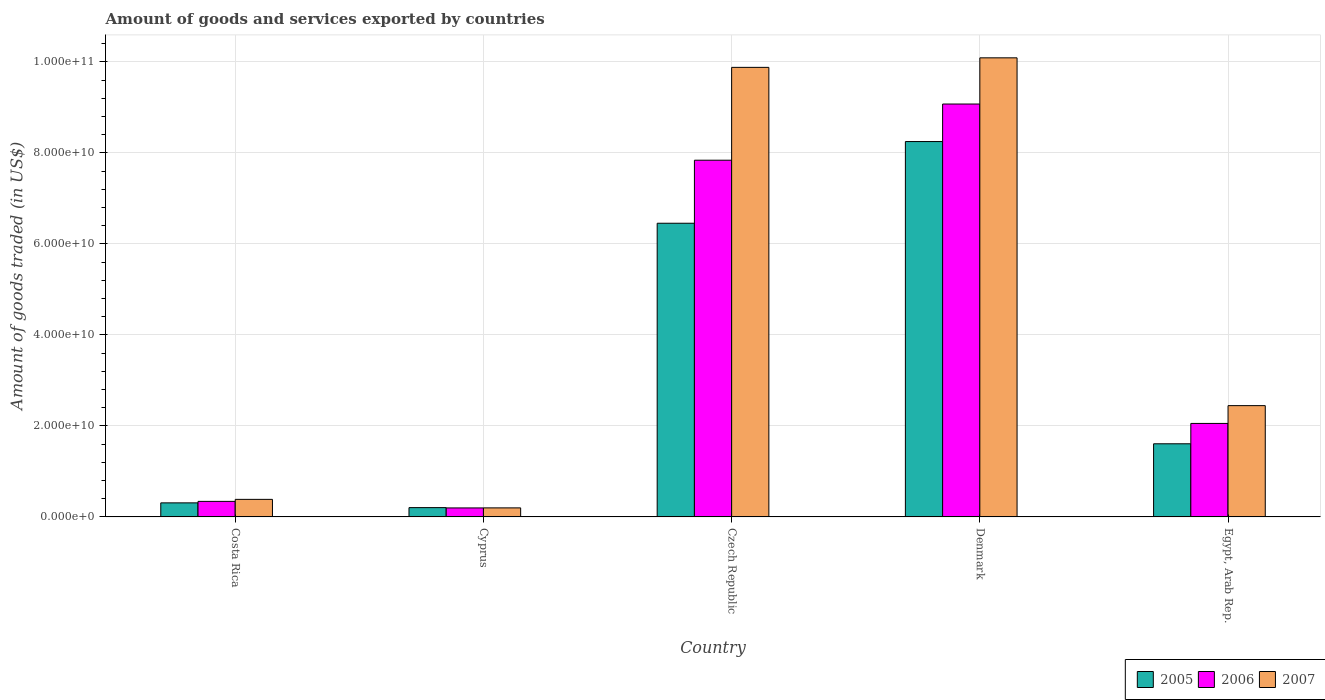How many groups of bars are there?
Give a very brief answer. 5. Are the number of bars per tick equal to the number of legend labels?
Provide a succinct answer. Yes. How many bars are there on the 4th tick from the left?
Give a very brief answer. 3. How many bars are there on the 4th tick from the right?
Keep it short and to the point. 3. What is the label of the 5th group of bars from the left?
Provide a succinct answer. Egypt, Arab Rep. What is the total amount of goods and services exported in 2006 in Denmark?
Keep it short and to the point. 9.07e+1. Across all countries, what is the maximum total amount of goods and services exported in 2007?
Keep it short and to the point. 1.01e+11. Across all countries, what is the minimum total amount of goods and services exported in 2006?
Give a very brief answer. 1.98e+09. In which country was the total amount of goods and services exported in 2005 minimum?
Your response must be concise. Cyprus. What is the total total amount of goods and services exported in 2005 in the graph?
Give a very brief answer. 1.68e+11. What is the difference between the total amount of goods and services exported in 2006 in Cyprus and that in Czech Republic?
Ensure brevity in your answer.  -7.64e+1. What is the difference between the total amount of goods and services exported in 2006 in Cyprus and the total amount of goods and services exported in 2007 in Czech Republic?
Make the answer very short. -9.68e+1. What is the average total amount of goods and services exported in 2007 per country?
Your answer should be very brief. 4.60e+1. What is the difference between the total amount of goods and services exported of/in 2006 and total amount of goods and services exported of/in 2007 in Egypt, Arab Rep.?
Give a very brief answer. -3.91e+09. In how many countries, is the total amount of goods and services exported in 2007 greater than 24000000000 US$?
Your answer should be very brief. 3. What is the ratio of the total amount of goods and services exported in 2005 in Costa Rica to that in Czech Republic?
Keep it short and to the point. 0.05. Is the total amount of goods and services exported in 2006 in Costa Rica less than that in Denmark?
Offer a terse response. Yes. Is the difference between the total amount of goods and services exported in 2006 in Costa Rica and Egypt, Arab Rep. greater than the difference between the total amount of goods and services exported in 2007 in Costa Rica and Egypt, Arab Rep.?
Your answer should be compact. Yes. What is the difference between the highest and the second highest total amount of goods and services exported in 2005?
Your answer should be compact. -4.85e+1. What is the difference between the highest and the lowest total amount of goods and services exported in 2005?
Your answer should be compact. 8.04e+1. In how many countries, is the total amount of goods and services exported in 2005 greater than the average total amount of goods and services exported in 2005 taken over all countries?
Offer a very short reply. 2. Is the sum of the total amount of goods and services exported in 2005 in Czech Republic and Egypt, Arab Rep. greater than the maximum total amount of goods and services exported in 2007 across all countries?
Give a very brief answer. No. Are all the bars in the graph horizontal?
Offer a very short reply. No. How many countries are there in the graph?
Your response must be concise. 5. What is the difference between two consecutive major ticks on the Y-axis?
Your response must be concise. 2.00e+1. Are the values on the major ticks of Y-axis written in scientific E-notation?
Offer a very short reply. Yes. How many legend labels are there?
Your answer should be very brief. 3. How are the legend labels stacked?
Keep it short and to the point. Horizontal. What is the title of the graph?
Provide a succinct answer. Amount of goods and services exported by countries. Does "1966" appear as one of the legend labels in the graph?
Give a very brief answer. No. What is the label or title of the Y-axis?
Your answer should be compact. Amount of goods traded (in US$). What is the Amount of goods traded (in US$) of 2005 in Costa Rica?
Your answer should be very brief. 3.09e+09. What is the Amount of goods traded (in US$) in 2006 in Costa Rica?
Your answer should be compact. 3.42e+09. What is the Amount of goods traded (in US$) in 2007 in Costa Rica?
Provide a short and direct response. 3.86e+09. What is the Amount of goods traded (in US$) in 2005 in Cyprus?
Your answer should be compact. 2.05e+09. What is the Amount of goods traded (in US$) in 2006 in Cyprus?
Your response must be concise. 1.98e+09. What is the Amount of goods traded (in US$) of 2007 in Cyprus?
Ensure brevity in your answer.  1.99e+09. What is the Amount of goods traded (in US$) of 2005 in Czech Republic?
Offer a terse response. 6.45e+1. What is the Amount of goods traded (in US$) in 2006 in Czech Republic?
Your answer should be compact. 7.84e+1. What is the Amount of goods traded (in US$) of 2007 in Czech Republic?
Provide a succinct answer. 9.88e+1. What is the Amount of goods traded (in US$) of 2005 in Denmark?
Give a very brief answer. 8.25e+1. What is the Amount of goods traded (in US$) of 2006 in Denmark?
Your answer should be very brief. 9.07e+1. What is the Amount of goods traded (in US$) of 2007 in Denmark?
Keep it short and to the point. 1.01e+11. What is the Amount of goods traded (in US$) of 2005 in Egypt, Arab Rep.?
Your response must be concise. 1.61e+1. What is the Amount of goods traded (in US$) in 2006 in Egypt, Arab Rep.?
Ensure brevity in your answer.  2.05e+1. What is the Amount of goods traded (in US$) in 2007 in Egypt, Arab Rep.?
Your answer should be compact. 2.45e+1. Across all countries, what is the maximum Amount of goods traded (in US$) of 2005?
Your response must be concise. 8.25e+1. Across all countries, what is the maximum Amount of goods traded (in US$) in 2006?
Your response must be concise. 9.07e+1. Across all countries, what is the maximum Amount of goods traded (in US$) of 2007?
Provide a succinct answer. 1.01e+11. Across all countries, what is the minimum Amount of goods traded (in US$) of 2005?
Ensure brevity in your answer.  2.05e+09. Across all countries, what is the minimum Amount of goods traded (in US$) in 2006?
Offer a terse response. 1.98e+09. Across all countries, what is the minimum Amount of goods traded (in US$) in 2007?
Provide a short and direct response. 1.99e+09. What is the total Amount of goods traded (in US$) of 2005 in the graph?
Provide a succinct answer. 1.68e+11. What is the total Amount of goods traded (in US$) in 2006 in the graph?
Provide a short and direct response. 1.95e+11. What is the total Amount of goods traded (in US$) of 2007 in the graph?
Give a very brief answer. 2.30e+11. What is the difference between the Amount of goods traded (in US$) of 2005 in Costa Rica and that in Cyprus?
Your answer should be very brief. 1.04e+09. What is the difference between the Amount of goods traded (in US$) in 2006 in Costa Rica and that in Cyprus?
Give a very brief answer. 1.44e+09. What is the difference between the Amount of goods traded (in US$) of 2007 in Costa Rica and that in Cyprus?
Keep it short and to the point. 1.87e+09. What is the difference between the Amount of goods traded (in US$) of 2005 in Costa Rica and that in Czech Republic?
Give a very brief answer. -6.14e+1. What is the difference between the Amount of goods traded (in US$) in 2006 in Costa Rica and that in Czech Republic?
Provide a succinct answer. -7.50e+1. What is the difference between the Amount of goods traded (in US$) of 2007 in Costa Rica and that in Czech Republic?
Offer a terse response. -9.49e+1. What is the difference between the Amount of goods traded (in US$) of 2005 in Costa Rica and that in Denmark?
Provide a succinct answer. -7.94e+1. What is the difference between the Amount of goods traded (in US$) in 2006 in Costa Rica and that in Denmark?
Offer a terse response. -8.73e+1. What is the difference between the Amount of goods traded (in US$) in 2007 in Costa Rica and that in Denmark?
Your answer should be very brief. -9.70e+1. What is the difference between the Amount of goods traded (in US$) of 2005 in Costa Rica and that in Egypt, Arab Rep.?
Your response must be concise. -1.30e+1. What is the difference between the Amount of goods traded (in US$) in 2006 in Costa Rica and that in Egypt, Arab Rep.?
Offer a terse response. -1.71e+1. What is the difference between the Amount of goods traded (in US$) of 2007 in Costa Rica and that in Egypt, Arab Rep.?
Offer a terse response. -2.06e+1. What is the difference between the Amount of goods traded (in US$) in 2005 in Cyprus and that in Czech Republic?
Offer a terse response. -6.25e+1. What is the difference between the Amount of goods traded (in US$) of 2006 in Cyprus and that in Czech Republic?
Ensure brevity in your answer.  -7.64e+1. What is the difference between the Amount of goods traded (in US$) in 2007 in Cyprus and that in Czech Republic?
Provide a succinct answer. -9.68e+1. What is the difference between the Amount of goods traded (in US$) in 2005 in Cyprus and that in Denmark?
Keep it short and to the point. -8.04e+1. What is the difference between the Amount of goods traded (in US$) in 2006 in Cyprus and that in Denmark?
Keep it short and to the point. -8.88e+1. What is the difference between the Amount of goods traded (in US$) of 2007 in Cyprus and that in Denmark?
Offer a terse response. -9.89e+1. What is the difference between the Amount of goods traded (in US$) of 2005 in Cyprus and that in Egypt, Arab Rep.?
Offer a very short reply. -1.40e+1. What is the difference between the Amount of goods traded (in US$) in 2006 in Cyprus and that in Egypt, Arab Rep.?
Make the answer very short. -1.86e+1. What is the difference between the Amount of goods traded (in US$) of 2007 in Cyprus and that in Egypt, Arab Rep.?
Make the answer very short. -2.25e+1. What is the difference between the Amount of goods traded (in US$) in 2005 in Czech Republic and that in Denmark?
Give a very brief answer. -1.80e+1. What is the difference between the Amount of goods traded (in US$) of 2006 in Czech Republic and that in Denmark?
Your response must be concise. -1.23e+1. What is the difference between the Amount of goods traded (in US$) in 2007 in Czech Republic and that in Denmark?
Your response must be concise. -2.09e+09. What is the difference between the Amount of goods traded (in US$) in 2005 in Czech Republic and that in Egypt, Arab Rep.?
Give a very brief answer. 4.85e+1. What is the difference between the Amount of goods traded (in US$) in 2006 in Czech Republic and that in Egypt, Arab Rep.?
Provide a short and direct response. 5.78e+1. What is the difference between the Amount of goods traded (in US$) in 2007 in Czech Republic and that in Egypt, Arab Rep.?
Give a very brief answer. 7.43e+1. What is the difference between the Amount of goods traded (in US$) of 2005 in Denmark and that in Egypt, Arab Rep.?
Provide a short and direct response. 6.64e+1. What is the difference between the Amount of goods traded (in US$) in 2006 in Denmark and that in Egypt, Arab Rep.?
Offer a very short reply. 7.02e+1. What is the difference between the Amount of goods traded (in US$) of 2007 in Denmark and that in Egypt, Arab Rep.?
Your response must be concise. 7.64e+1. What is the difference between the Amount of goods traded (in US$) of 2005 in Costa Rica and the Amount of goods traded (in US$) of 2006 in Cyprus?
Provide a succinct answer. 1.11e+09. What is the difference between the Amount of goods traded (in US$) in 2005 in Costa Rica and the Amount of goods traded (in US$) in 2007 in Cyprus?
Provide a short and direct response. 1.10e+09. What is the difference between the Amount of goods traded (in US$) of 2006 in Costa Rica and the Amount of goods traded (in US$) of 2007 in Cyprus?
Keep it short and to the point. 1.43e+09. What is the difference between the Amount of goods traded (in US$) of 2005 in Costa Rica and the Amount of goods traded (in US$) of 2006 in Czech Republic?
Give a very brief answer. -7.53e+1. What is the difference between the Amount of goods traded (in US$) in 2005 in Costa Rica and the Amount of goods traded (in US$) in 2007 in Czech Republic?
Offer a very short reply. -9.57e+1. What is the difference between the Amount of goods traded (in US$) in 2006 in Costa Rica and the Amount of goods traded (in US$) in 2007 in Czech Republic?
Provide a short and direct response. -9.54e+1. What is the difference between the Amount of goods traded (in US$) in 2005 in Costa Rica and the Amount of goods traded (in US$) in 2006 in Denmark?
Ensure brevity in your answer.  -8.76e+1. What is the difference between the Amount of goods traded (in US$) in 2005 in Costa Rica and the Amount of goods traded (in US$) in 2007 in Denmark?
Keep it short and to the point. -9.78e+1. What is the difference between the Amount of goods traded (in US$) in 2006 in Costa Rica and the Amount of goods traded (in US$) in 2007 in Denmark?
Offer a very short reply. -9.75e+1. What is the difference between the Amount of goods traded (in US$) in 2005 in Costa Rica and the Amount of goods traded (in US$) in 2006 in Egypt, Arab Rep.?
Give a very brief answer. -1.75e+1. What is the difference between the Amount of goods traded (in US$) of 2005 in Costa Rica and the Amount of goods traded (in US$) of 2007 in Egypt, Arab Rep.?
Offer a very short reply. -2.14e+1. What is the difference between the Amount of goods traded (in US$) in 2006 in Costa Rica and the Amount of goods traded (in US$) in 2007 in Egypt, Arab Rep.?
Your answer should be compact. -2.10e+1. What is the difference between the Amount of goods traded (in US$) in 2005 in Cyprus and the Amount of goods traded (in US$) in 2006 in Czech Republic?
Keep it short and to the point. -7.63e+1. What is the difference between the Amount of goods traded (in US$) in 2005 in Cyprus and the Amount of goods traded (in US$) in 2007 in Czech Republic?
Ensure brevity in your answer.  -9.67e+1. What is the difference between the Amount of goods traded (in US$) of 2006 in Cyprus and the Amount of goods traded (in US$) of 2007 in Czech Republic?
Ensure brevity in your answer.  -9.68e+1. What is the difference between the Amount of goods traded (in US$) of 2005 in Cyprus and the Amount of goods traded (in US$) of 2006 in Denmark?
Your answer should be compact. -8.87e+1. What is the difference between the Amount of goods traded (in US$) in 2005 in Cyprus and the Amount of goods traded (in US$) in 2007 in Denmark?
Make the answer very short. -9.88e+1. What is the difference between the Amount of goods traded (in US$) of 2006 in Cyprus and the Amount of goods traded (in US$) of 2007 in Denmark?
Give a very brief answer. -9.89e+1. What is the difference between the Amount of goods traded (in US$) of 2005 in Cyprus and the Amount of goods traded (in US$) of 2006 in Egypt, Arab Rep.?
Ensure brevity in your answer.  -1.85e+1. What is the difference between the Amount of goods traded (in US$) in 2005 in Cyprus and the Amount of goods traded (in US$) in 2007 in Egypt, Arab Rep.?
Make the answer very short. -2.24e+1. What is the difference between the Amount of goods traded (in US$) in 2006 in Cyprus and the Amount of goods traded (in US$) in 2007 in Egypt, Arab Rep.?
Keep it short and to the point. -2.25e+1. What is the difference between the Amount of goods traded (in US$) in 2005 in Czech Republic and the Amount of goods traded (in US$) in 2006 in Denmark?
Ensure brevity in your answer.  -2.62e+1. What is the difference between the Amount of goods traded (in US$) in 2005 in Czech Republic and the Amount of goods traded (in US$) in 2007 in Denmark?
Your response must be concise. -3.63e+1. What is the difference between the Amount of goods traded (in US$) of 2006 in Czech Republic and the Amount of goods traded (in US$) of 2007 in Denmark?
Offer a terse response. -2.25e+1. What is the difference between the Amount of goods traded (in US$) of 2005 in Czech Republic and the Amount of goods traded (in US$) of 2006 in Egypt, Arab Rep.?
Provide a short and direct response. 4.40e+1. What is the difference between the Amount of goods traded (in US$) in 2005 in Czech Republic and the Amount of goods traded (in US$) in 2007 in Egypt, Arab Rep.?
Your answer should be very brief. 4.01e+1. What is the difference between the Amount of goods traded (in US$) in 2006 in Czech Republic and the Amount of goods traded (in US$) in 2007 in Egypt, Arab Rep.?
Your response must be concise. 5.39e+1. What is the difference between the Amount of goods traded (in US$) of 2005 in Denmark and the Amount of goods traded (in US$) of 2006 in Egypt, Arab Rep.?
Ensure brevity in your answer.  6.19e+1. What is the difference between the Amount of goods traded (in US$) of 2005 in Denmark and the Amount of goods traded (in US$) of 2007 in Egypt, Arab Rep.?
Your answer should be very brief. 5.80e+1. What is the difference between the Amount of goods traded (in US$) of 2006 in Denmark and the Amount of goods traded (in US$) of 2007 in Egypt, Arab Rep.?
Provide a short and direct response. 6.63e+1. What is the average Amount of goods traded (in US$) of 2005 per country?
Provide a succinct answer. 3.36e+1. What is the average Amount of goods traded (in US$) of 2006 per country?
Provide a short and direct response. 3.90e+1. What is the average Amount of goods traded (in US$) in 2007 per country?
Make the answer very short. 4.60e+1. What is the difference between the Amount of goods traded (in US$) of 2005 and Amount of goods traded (in US$) of 2006 in Costa Rica?
Your response must be concise. -3.27e+08. What is the difference between the Amount of goods traded (in US$) in 2005 and Amount of goods traded (in US$) in 2007 in Costa Rica?
Ensure brevity in your answer.  -7.72e+08. What is the difference between the Amount of goods traded (in US$) of 2006 and Amount of goods traded (in US$) of 2007 in Costa Rica?
Make the answer very short. -4.45e+08. What is the difference between the Amount of goods traded (in US$) in 2005 and Amount of goods traded (in US$) in 2006 in Cyprus?
Provide a succinct answer. 6.64e+07. What is the difference between the Amount of goods traded (in US$) of 2005 and Amount of goods traded (in US$) of 2007 in Cyprus?
Your answer should be compact. 5.92e+07. What is the difference between the Amount of goods traded (in US$) of 2006 and Amount of goods traded (in US$) of 2007 in Cyprus?
Make the answer very short. -7.27e+06. What is the difference between the Amount of goods traded (in US$) in 2005 and Amount of goods traded (in US$) in 2006 in Czech Republic?
Ensure brevity in your answer.  -1.38e+1. What is the difference between the Amount of goods traded (in US$) of 2005 and Amount of goods traded (in US$) of 2007 in Czech Republic?
Your answer should be very brief. -3.43e+1. What is the difference between the Amount of goods traded (in US$) in 2006 and Amount of goods traded (in US$) in 2007 in Czech Republic?
Provide a succinct answer. -2.04e+1. What is the difference between the Amount of goods traded (in US$) of 2005 and Amount of goods traded (in US$) of 2006 in Denmark?
Ensure brevity in your answer.  -8.25e+09. What is the difference between the Amount of goods traded (in US$) of 2005 and Amount of goods traded (in US$) of 2007 in Denmark?
Give a very brief answer. -1.84e+1. What is the difference between the Amount of goods traded (in US$) in 2006 and Amount of goods traded (in US$) in 2007 in Denmark?
Give a very brief answer. -1.01e+1. What is the difference between the Amount of goods traded (in US$) in 2005 and Amount of goods traded (in US$) in 2006 in Egypt, Arab Rep.?
Offer a terse response. -4.47e+09. What is the difference between the Amount of goods traded (in US$) of 2005 and Amount of goods traded (in US$) of 2007 in Egypt, Arab Rep.?
Provide a short and direct response. -8.38e+09. What is the difference between the Amount of goods traded (in US$) in 2006 and Amount of goods traded (in US$) in 2007 in Egypt, Arab Rep.?
Keep it short and to the point. -3.91e+09. What is the ratio of the Amount of goods traded (in US$) in 2005 in Costa Rica to that in Cyprus?
Provide a short and direct response. 1.51. What is the ratio of the Amount of goods traded (in US$) of 2006 in Costa Rica to that in Cyprus?
Provide a succinct answer. 1.73. What is the ratio of the Amount of goods traded (in US$) in 2007 in Costa Rica to that in Cyprus?
Offer a very short reply. 1.94. What is the ratio of the Amount of goods traded (in US$) of 2005 in Costa Rica to that in Czech Republic?
Give a very brief answer. 0.05. What is the ratio of the Amount of goods traded (in US$) of 2006 in Costa Rica to that in Czech Republic?
Ensure brevity in your answer.  0.04. What is the ratio of the Amount of goods traded (in US$) in 2007 in Costa Rica to that in Czech Republic?
Your response must be concise. 0.04. What is the ratio of the Amount of goods traded (in US$) in 2005 in Costa Rica to that in Denmark?
Provide a succinct answer. 0.04. What is the ratio of the Amount of goods traded (in US$) in 2006 in Costa Rica to that in Denmark?
Give a very brief answer. 0.04. What is the ratio of the Amount of goods traded (in US$) of 2007 in Costa Rica to that in Denmark?
Give a very brief answer. 0.04. What is the ratio of the Amount of goods traded (in US$) in 2005 in Costa Rica to that in Egypt, Arab Rep.?
Give a very brief answer. 0.19. What is the ratio of the Amount of goods traded (in US$) in 2006 in Costa Rica to that in Egypt, Arab Rep.?
Provide a succinct answer. 0.17. What is the ratio of the Amount of goods traded (in US$) in 2007 in Costa Rica to that in Egypt, Arab Rep.?
Your answer should be compact. 0.16. What is the ratio of the Amount of goods traded (in US$) in 2005 in Cyprus to that in Czech Republic?
Make the answer very short. 0.03. What is the ratio of the Amount of goods traded (in US$) of 2006 in Cyprus to that in Czech Republic?
Offer a very short reply. 0.03. What is the ratio of the Amount of goods traded (in US$) in 2007 in Cyprus to that in Czech Republic?
Your answer should be compact. 0.02. What is the ratio of the Amount of goods traded (in US$) of 2005 in Cyprus to that in Denmark?
Your response must be concise. 0.02. What is the ratio of the Amount of goods traded (in US$) of 2006 in Cyprus to that in Denmark?
Your answer should be compact. 0.02. What is the ratio of the Amount of goods traded (in US$) in 2007 in Cyprus to that in Denmark?
Keep it short and to the point. 0.02. What is the ratio of the Amount of goods traded (in US$) of 2005 in Cyprus to that in Egypt, Arab Rep.?
Give a very brief answer. 0.13. What is the ratio of the Amount of goods traded (in US$) of 2006 in Cyprus to that in Egypt, Arab Rep.?
Your answer should be compact. 0.1. What is the ratio of the Amount of goods traded (in US$) of 2007 in Cyprus to that in Egypt, Arab Rep.?
Make the answer very short. 0.08. What is the ratio of the Amount of goods traded (in US$) in 2005 in Czech Republic to that in Denmark?
Offer a terse response. 0.78. What is the ratio of the Amount of goods traded (in US$) in 2006 in Czech Republic to that in Denmark?
Your response must be concise. 0.86. What is the ratio of the Amount of goods traded (in US$) of 2007 in Czech Republic to that in Denmark?
Give a very brief answer. 0.98. What is the ratio of the Amount of goods traded (in US$) in 2005 in Czech Republic to that in Egypt, Arab Rep.?
Provide a succinct answer. 4.02. What is the ratio of the Amount of goods traded (in US$) of 2006 in Czech Republic to that in Egypt, Arab Rep.?
Provide a succinct answer. 3.82. What is the ratio of the Amount of goods traded (in US$) in 2007 in Czech Republic to that in Egypt, Arab Rep.?
Provide a short and direct response. 4.04. What is the ratio of the Amount of goods traded (in US$) of 2005 in Denmark to that in Egypt, Arab Rep.?
Provide a succinct answer. 5.13. What is the ratio of the Amount of goods traded (in US$) in 2006 in Denmark to that in Egypt, Arab Rep.?
Provide a succinct answer. 4.42. What is the ratio of the Amount of goods traded (in US$) of 2007 in Denmark to that in Egypt, Arab Rep.?
Ensure brevity in your answer.  4.13. What is the difference between the highest and the second highest Amount of goods traded (in US$) in 2005?
Provide a succinct answer. 1.80e+1. What is the difference between the highest and the second highest Amount of goods traded (in US$) in 2006?
Your answer should be compact. 1.23e+1. What is the difference between the highest and the second highest Amount of goods traded (in US$) in 2007?
Your response must be concise. 2.09e+09. What is the difference between the highest and the lowest Amount of goods traded (in US$) of 2005?
Provide a short and direct response. 8.04e+1. What is the difference between the highest and the lowest Amount of goods traded (in US$) of 2006?
Offer a very short reply. 8.88e+1. What is the difference between the highest and the lowest Amount of goods traded (in US$) in 2007?
Offer a terse response. 9.89e+1. 